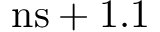Convert formula to latex. <formula><loc_0><loc_0><loc_500><loc_500>n s + 1 . 1</formula> 